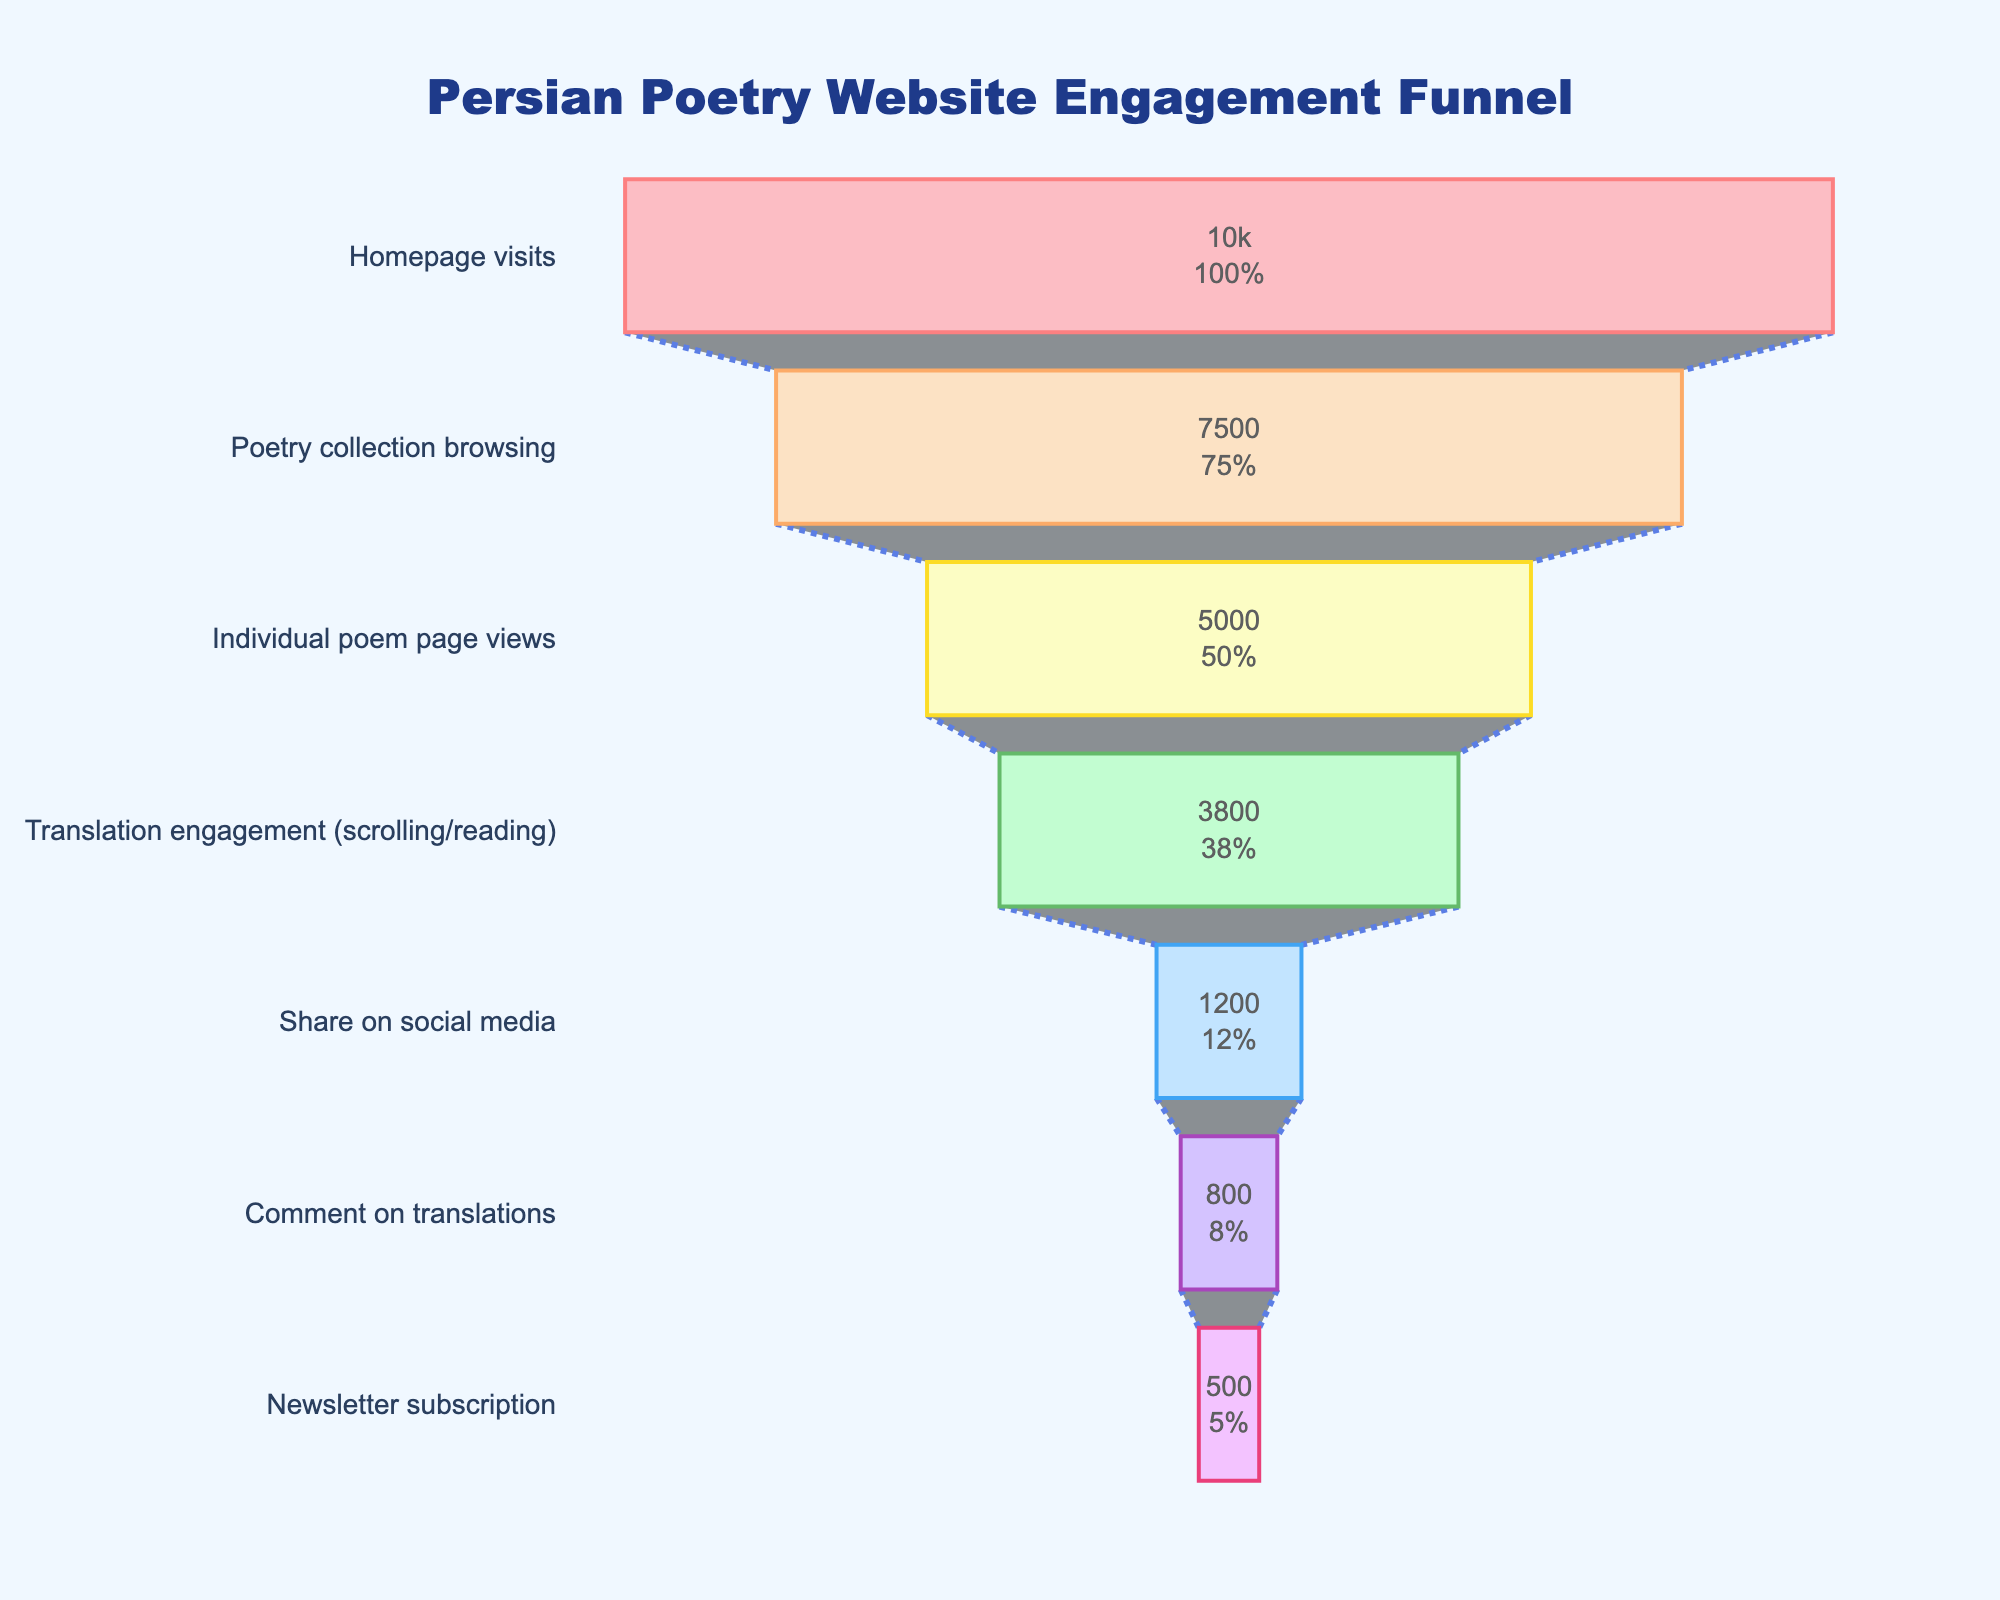what is the title of the figure? Locate the title at the top of the figure. It reads "Persian Poetry Website Engagement Funnel".
Answer: Persian Poetry Website Engagement Funnel How many stages are in the funnel chart? Count the number of stages listed from top to bottom, starting from "Homepage visits" to "Newsletter subscription". There are 7 stages.
Answer: 7 What is the percentage of visitors who moved from "Poetry collection browsing" to "Individual poem page views"? Observe the values for both stages. "Poetry collection browsing" has 7,500 visitors, and "Individual poem page views" has 5,000 visitors. The percentage can be calculated as (5000 / 7500) * 100.
Answer: 66.67% What color represents the "Comment on translations" stage? Refer to the colors in the chart. The "Comment on translations" stage is represented by a lavender color.
Answer: Lavender What stage has the largest drop in visitors? Compare the difference in visitor numbers between each consecutive stage. The largest drop is from "Translation engagement" (3,800) to "Share on social media" (1,200) with a drop of 2,600 visitors.
Answer: Translation engagement to Share on social media How many visitors subscribed to the newsletter as a percentage of "Homepage visits"? The number of newsletter subscribers is 500, and the number of homepage visits is 10,000. Calculate the percentage as (500 / 10000) * 100.
Answer: 5% Which stage has a greater number of visitors: "Translation engagement" or "Share on social media"? Compare the visitor numbers for both stages. "Translation engagement" has 3,800 visitors, and "Share on social media" has 1,200 visitors. 3,800 is greater than 1,200.
Answer: Translation engagement What is the percentage of visitors who engage with translations after visiting an individual poem page? Observe the number of visitors for the stages "Individual poem page views" (5,000) and "Translation engagement" (3,800). The percentage is calculated as (3,800 / 5,000) * 100.
Answer: 76% What is the last stage in the funnel? The last stage listed in the funnel chart is "Newsletter subscription".
Answer: Newsletter subscription What is the initial stage in this engagement funnel? The first stage listed in the funnel chart is "Homepage visits".
Answer: Homepage visits 